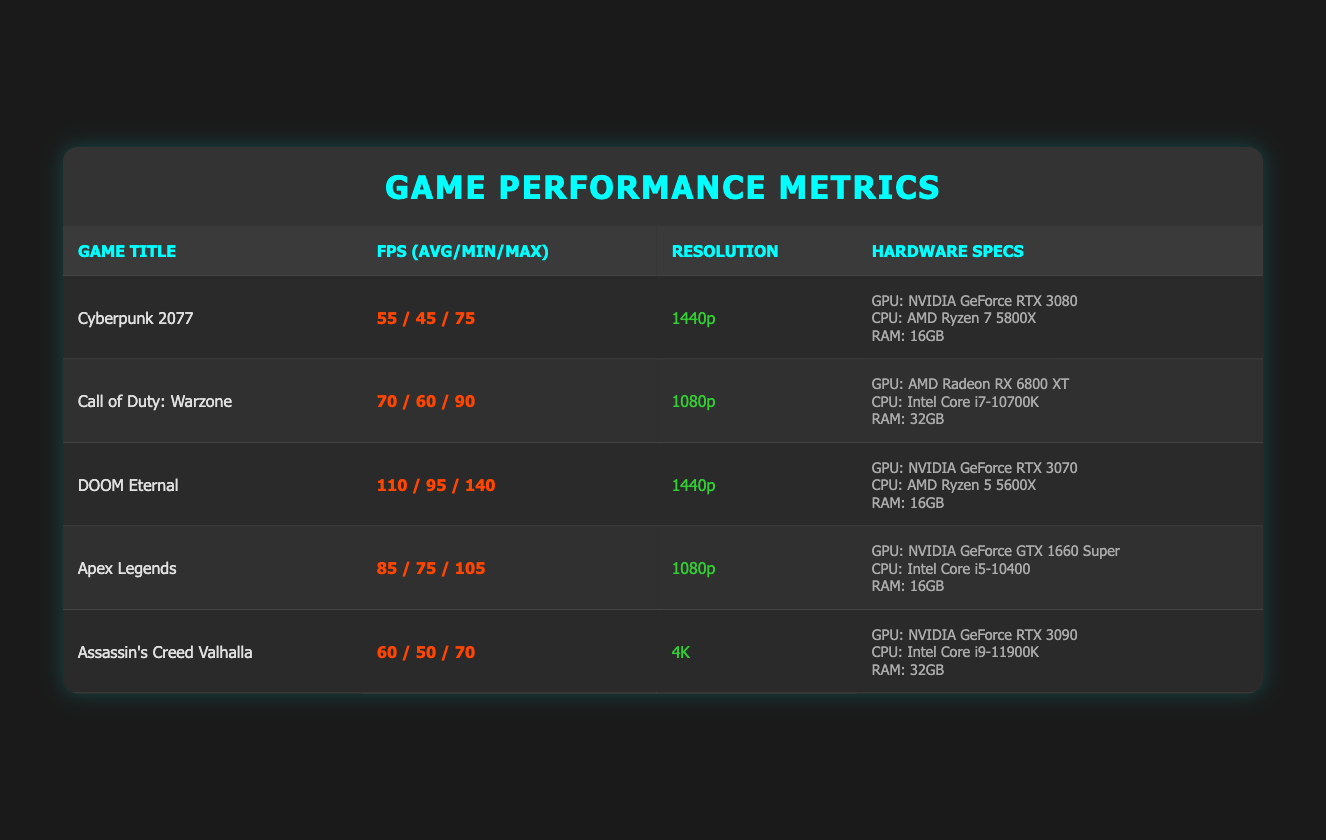What is the average frame rate for "DOOM Eternal"? The average frame rate for "DOOM Eternal" is listed in the table and is denoted as 110.
Answer: 110 Which game has the highest minimum frame rate? The games' minimum frame rates are: Cyberpunk 2077 (45), Call of Duty: Warzone (60), DOOM Eternal (95), Apex Legends (75), and Assassin's Creed Valhalla (50). Therefore, "DOOM Eternal" has the highest minimum frame rate of 95.
Answer: DOOM Eternal Is the RAM requirement for "Cyberpunk 2077" higher than for "Apex Legends"? "Cyberpunk 2077" requires 16GB of RAM, while "Apex Legends" also requires 16GB. Thus, the RAM requirement is not higher for "Cyberpunk 2077".
Answer: No What is the difference in average frame rates between "Call of Duty: Warzone" and "Assassin's Creed Valhalla"? The average frame rate for "Call of Duty: Warzone" is 70 and for "Assassin's Creed Valhalla" it is 60. The difference is calculated as 70 - 60 = 10.
Answer: 10 Which game has the highest maximum frame rate and what is that rate? The maximum frame rates for the games are: Cyberpunk 2077 (75), Call of Duty: Warzone (90), DOOM Eternal (140), Apex Legends (105), and Assassin's Creed Valhalla (70). "DOOM Eternal" has the highest maximum frame rate of 140.
Answer: DOOM Eternal, 140 Are any games listed with a resolution of 4K? The table shows "Assassin's Creed Valhalla" as having a resolution of 4K, which confirms that there is at least one game listed with that resolution.
Answer: Yes What is the average frame rate across all games listed? The average frame rate is calculated by adding all average frame rates: (55 + 70 + 110 + 85 + 60) = 380. There are 5 games, so the average is 380 / 5 = 76.
Answer: 76 Does "NVIDIA GeForce RTX 3080" provide a better average frame rate than "AMD Radeon RX 6800 XT"? The average frame rate for "Cyberpunk 2077" with "NVIDIA GeForce RTX 3080" is 55, while for "Call of Duty: Warzone" with "AMD Radeon RX 6800 XT" it is 70. Thus, "AMD Radeon RX 6800 XT" provides a better average frame rate.
Answer: No 